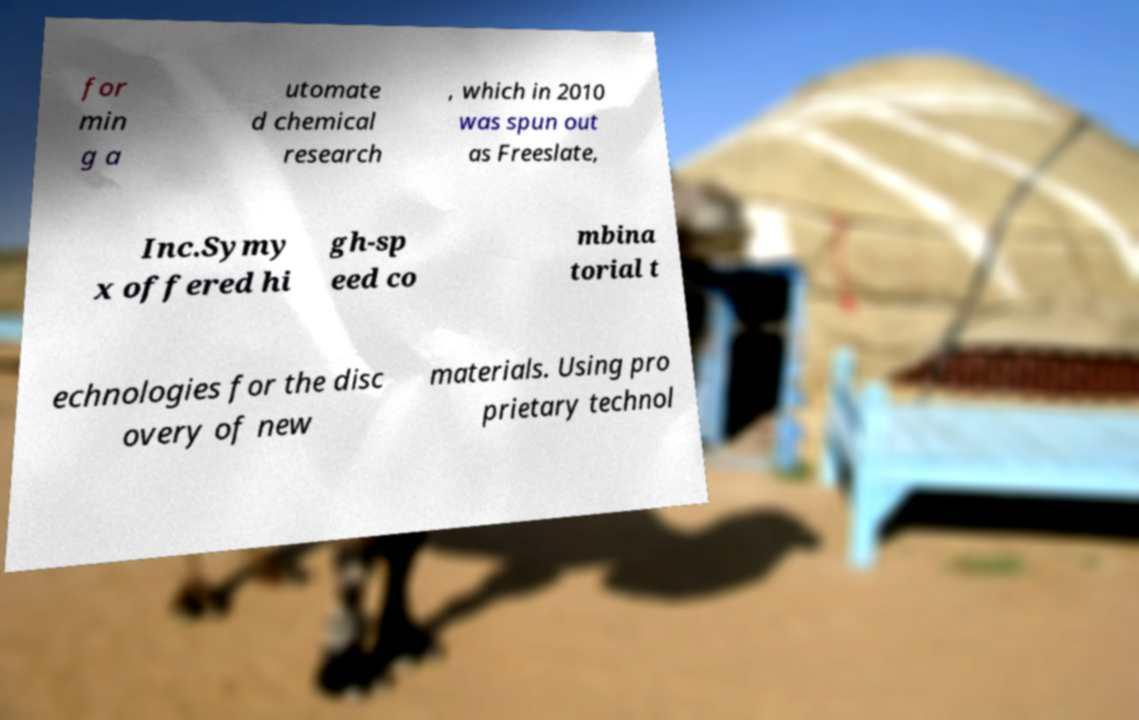Please identify and transcribe the text found in this image. for min g a utomate d chemical research , which in 2010 was spun out as Freeslate, Inc.Symy x offered hi gh-sp eed co mbina torial t echnologies for the disc overy of new materials. Using pro prietary technol 